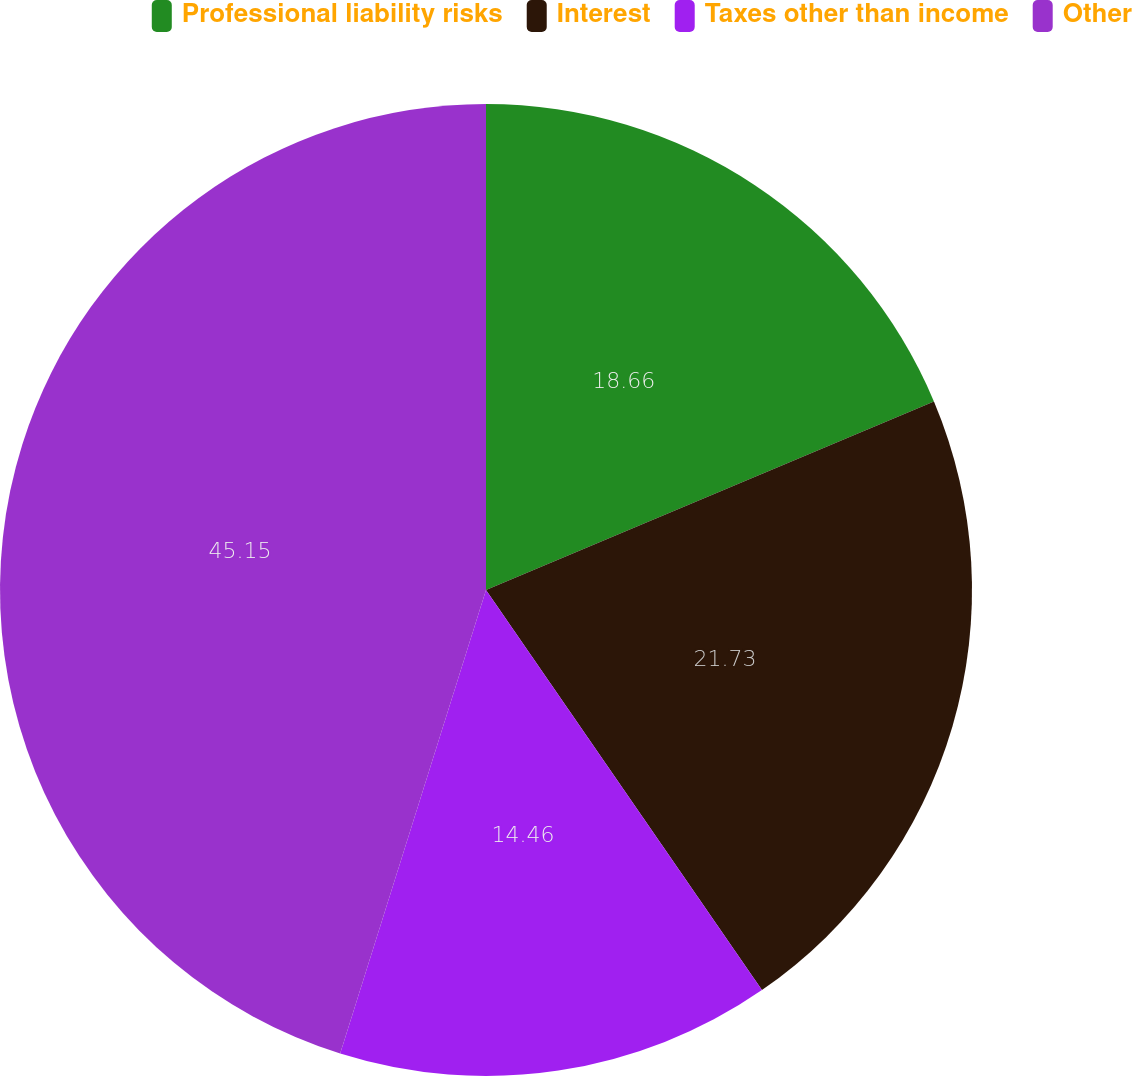Convert chart to OTSL. <chart><loc_0><loc_0><loc_500><loc_500><pie_chart><fcel>Professional liability risks<fcel>Interest<fcel>Taxes other than income<fcel>Other<nl><fcel>18.66%<fcel>21.73%<fcel>14.46%<fcel>45.15%<nl></chart> 